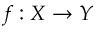Convert formula to latex. <formula><loc_0><loc_0><loc_500><loc_500>f \colon X \to Y</formula> 